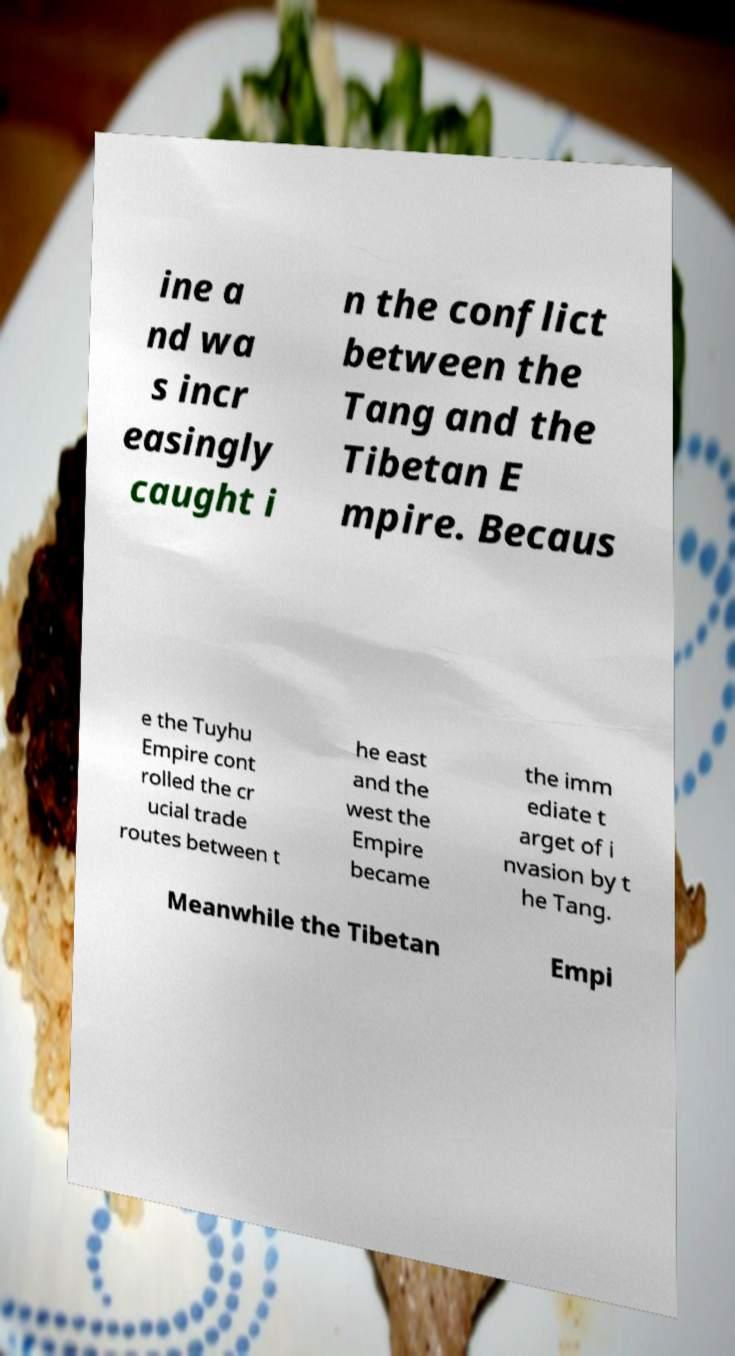I need the written content from this picture converted into text. Can you do that? ine a nd wa s incr easingly caught i n the conflict between the Tang and the Tibetan E mpire. Becaus e the Tuyhu Empire cont rolled the cr ucial trade routes between t he east and the west the Empire became the imm ediate t arget of i nvasion by t he Tang. Meanwhile the Tibetan Empi 